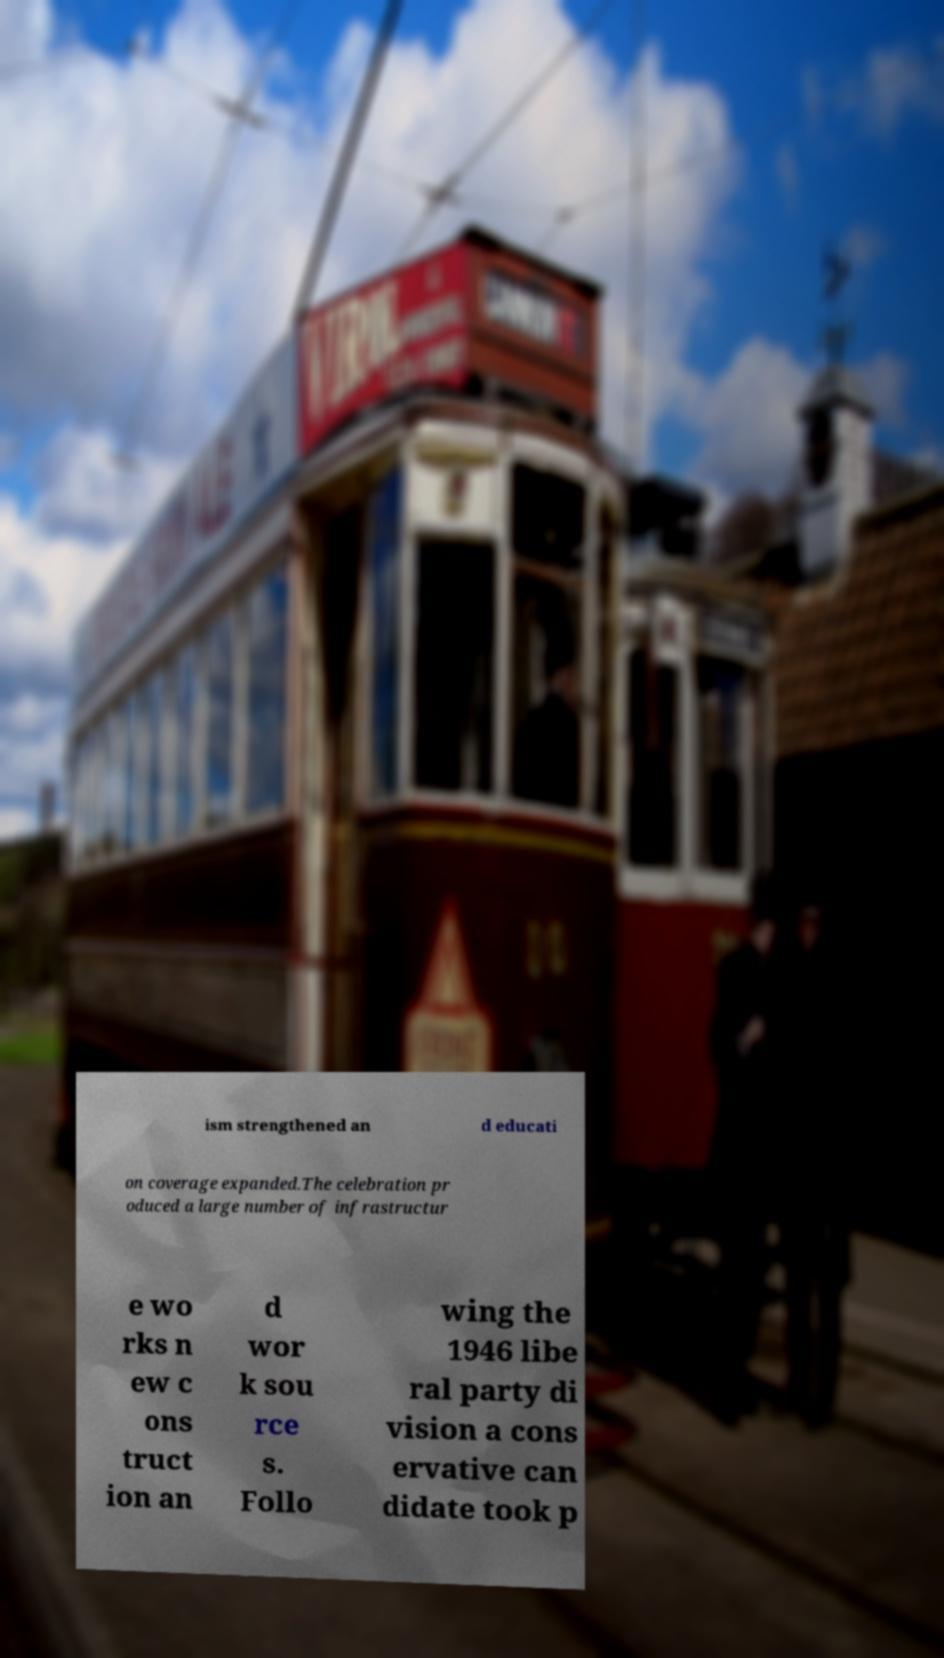Could you assist in decoding the text presented in this image and type it out clearly? ism strengthened an d educati on coverage expanded.The celebration pr oduced a large number of infrastructur e wo rks n ew c ons truct ion an d wor k sou rce s. Follo wing the 1946 libe ral party di vision a cons ervative can didate took p 